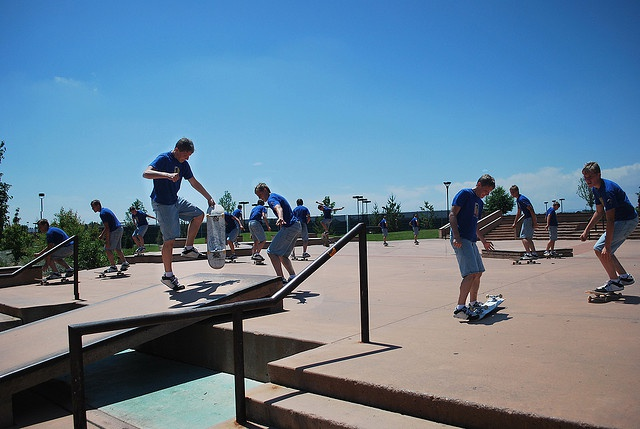Describe the objects in this image and their specific colors. I can see people in gray, black, maroon, and navy tones, people in gray, black, maroon, and navy tones, people in gray, black, maroon, and navy tones, people in gray, black, navy, and darkgray tones, and people in gray, navy, black, and maroon tones in this image. 